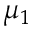<formula> <loc_0><loc_0><loc_500><loc_500>\mu _ { 1 }</formula> 